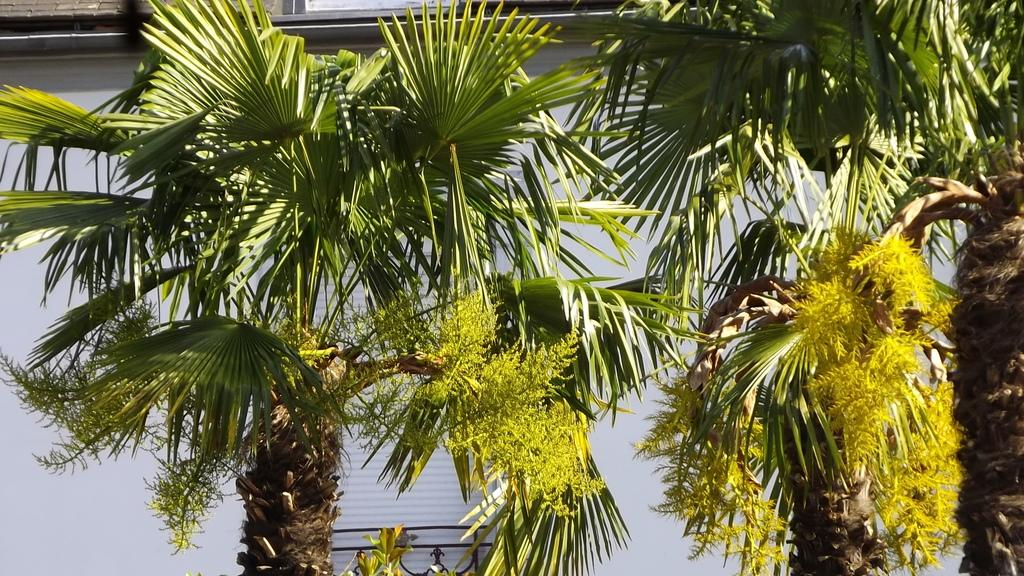What type of natural elements can be seen in the image? There are trees in the image. What type of man-made structure is visible in the background? There is a building in the background of the image. How many horses can be seen grazing in the image? There are no horses present in the image; it features trees and a building in the background. 